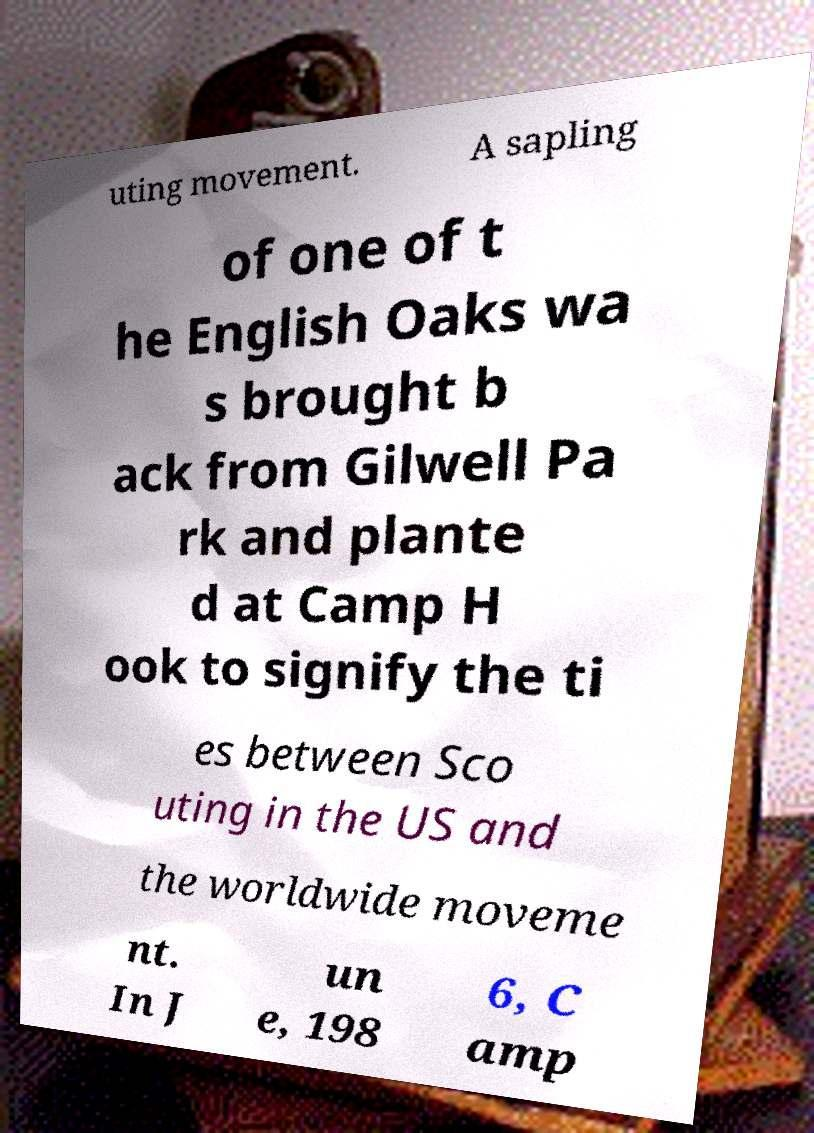Please identify and transcribe the text found in this image. uting movement. A sapling of one of t he English Oaks wa s brought b ack from Gilwell Pa rk and plante d at Camp H ook to signify the ti es between Sco uting in the US and the worldwide moveme nt. In J un e, 198 6, C amp 